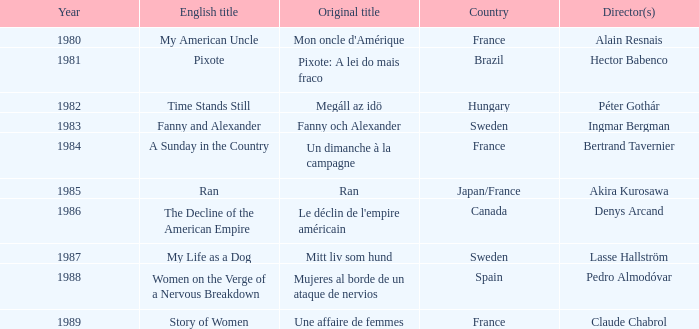What's the English Title of Fanny Och Alexander? Fanny and Alexander. 